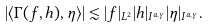<formula> <loc_0><loc_0><loc_500><loc_500>| \langle \Gamma ( f , h ) , \eta \rangle | \lesssim | f | _ { L ^ { 2 } } | h | _ { I ^ { a , \gamma } } | \eta | _ { I ^ { a , \gamma } } .</formula> 